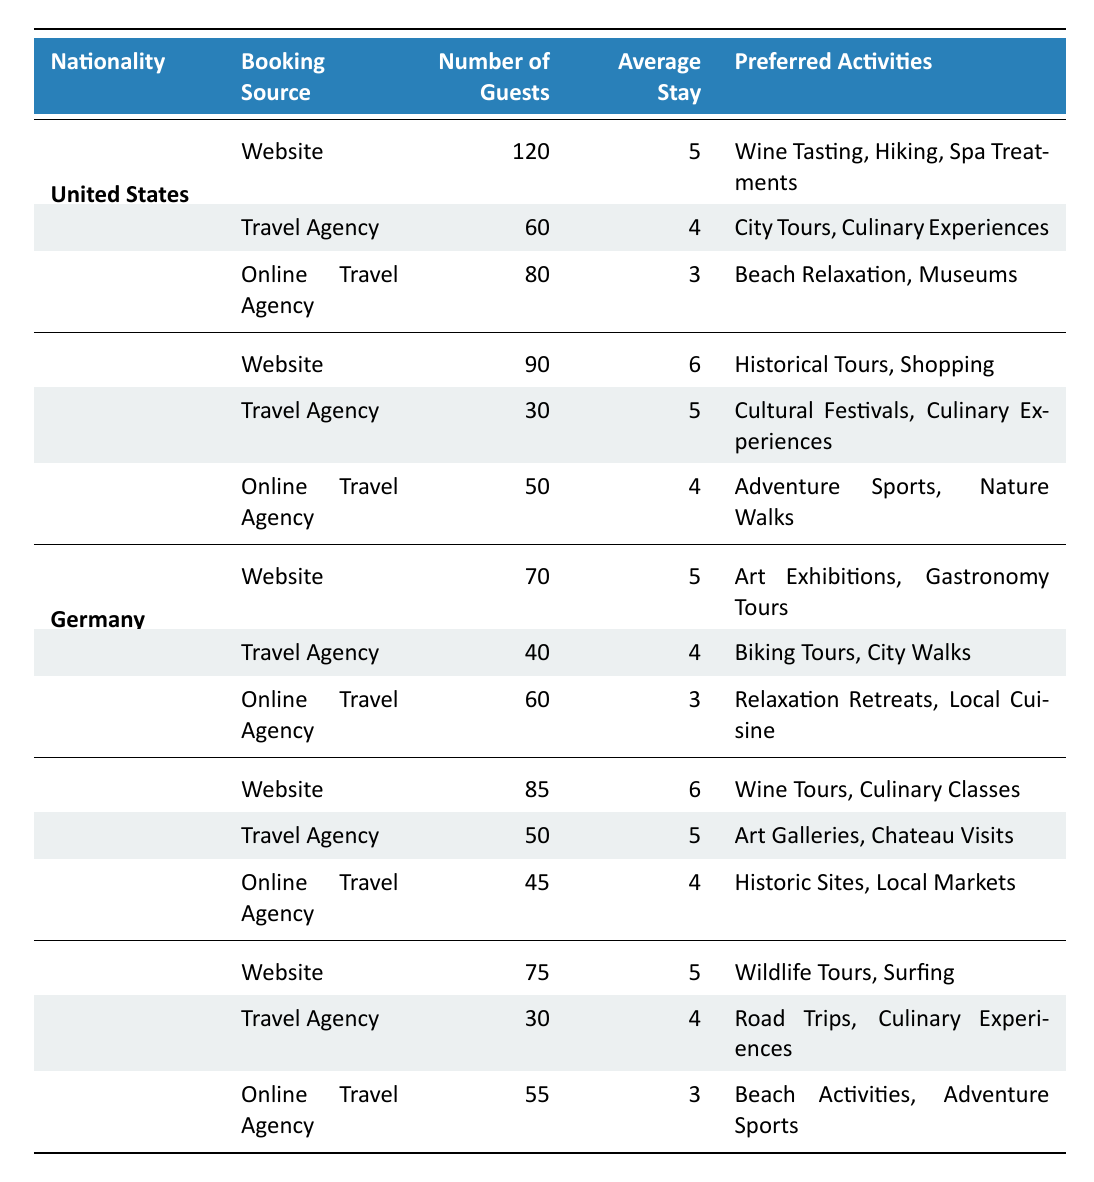What is the total number of guests from the United Kingdom? From the table, the United Kingdom has three booking sources: Website (90 guests), Travel Agency (30 guests), and Online Travel Agency (50 guests). Adding these together gives us 90 + 30 + 50 = 170 guests.
Answer: 170 Which nationality has the highest number of guests booking through the website? By examining the table, the United States has 120 guests, the United Kingdom has 90 guests, Germany has 70 guests, France has 85 guests, and Australia has 75 guests through the website. The highest is 120 from the United States.
Answer: United States What is the average stay of guests from Germany across all booking sources? The average stay for the three sources from Germany is: Website (5 days), Travel Agency (4 days), and Online Travel Agency (3 days). To find the average, sum these values: 5 + 4 + 3 = 12 days, then divide by 3 data points: 12/3 = 4 days.
Answer: 4 days Do more guests from Australia prefer Beach Activities or Wildlife Tours? According to the table, 55 guests from Australia prefer Beach Activities, while 75 guests prefer Wildlife Tours. Since 75 is greater than 55, more guests prefer Wildlife Tours.
Answer: Yes What is the preferred activity of guests from France who booked through a Travel Agency? The table specifies that for France, guests booking through Travel Agency have preferred activities of Art Galleries and Chateau Visits.
Answer: Art Galleries, Chateau Visits Which nationality has the second-highest average stay overall? We need to calculate the average stay for each nationality: USA (4 days), UK (5 days), Germany (4 days), France (5 days), Australia (4 days). Sorting these, United Kingdom and France both have 5 days. Since the UK is first, France is second overall with 5 days.
Answer: France Are the majority of guests from Germany more likely to book through the Website than the Online Travel Agency? The table shows Germany has 70 guests booking through the Website and 60 through the Online Travel Agency. Since 70 is greater than 60, the majority prefers the Website over the Online Travel Agency.
Answer: Yes What combination of activities do guests from the United States prefer when booking through an Online Travel Agency? The table indicates that guests from the United States booking through an Online Travel Agency prefer Beach Relaxation and Museums. Therefore, the combination of these activities represents their preference.
Answer: Beach Relaxation, Museums How many guests booked through the Online Travel Agency across all nationalities? The total number of guests booking through the Online Travel Agency is calculated by summing: USA (80), UK (50), Germany (60), France (45), and Australia (55). The total is 80 + 50 + 60 + 45 + 55 = 290 guests.
Answer: 290 